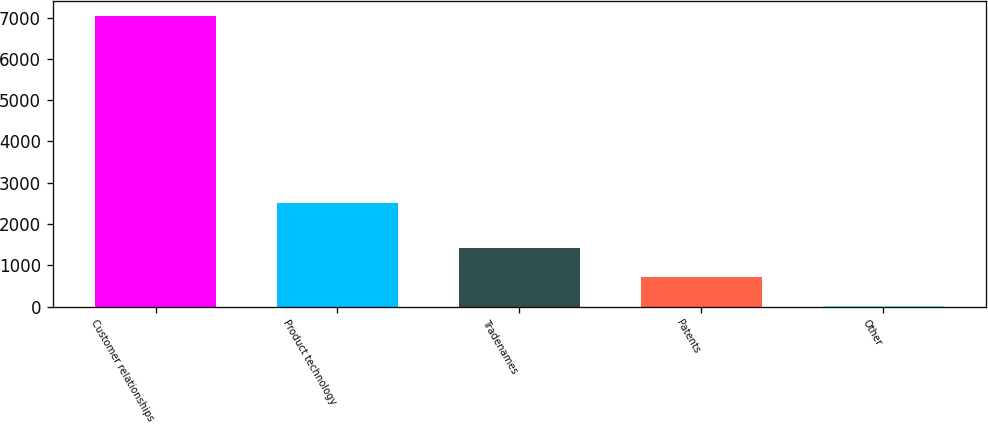Convert chart to OTSL. <chart><loc_0><loc_0><loc_500><loc_500><bar_chart><fcel>Customer relationships<fcel>Product technology<fcel>Tradenames<fcel>Patents<fcel>Other<nl><fcel>7047<fcel>2512.9<fcel>1421.96<fcel>718.83<fcel>15.7<nl></chart> 